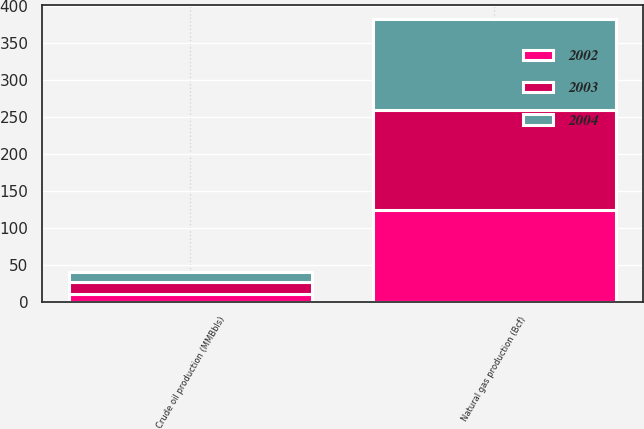Convert chart to OTSL. <chart><loc_0><loc_0><loc_500><loc_500><stacked_bar_chart><ecel><fcel>Crude oil production (MMBbls)<fcel>Natural gas production (Bcf)<nl><fcel>2003<fcel>16.6<fcel>134.3<nl><fcel>2004<fcel>13.1<fcel>122.9<nl><fcel>2002<fcel>10.6<fcel>124.5<nl></chart> 